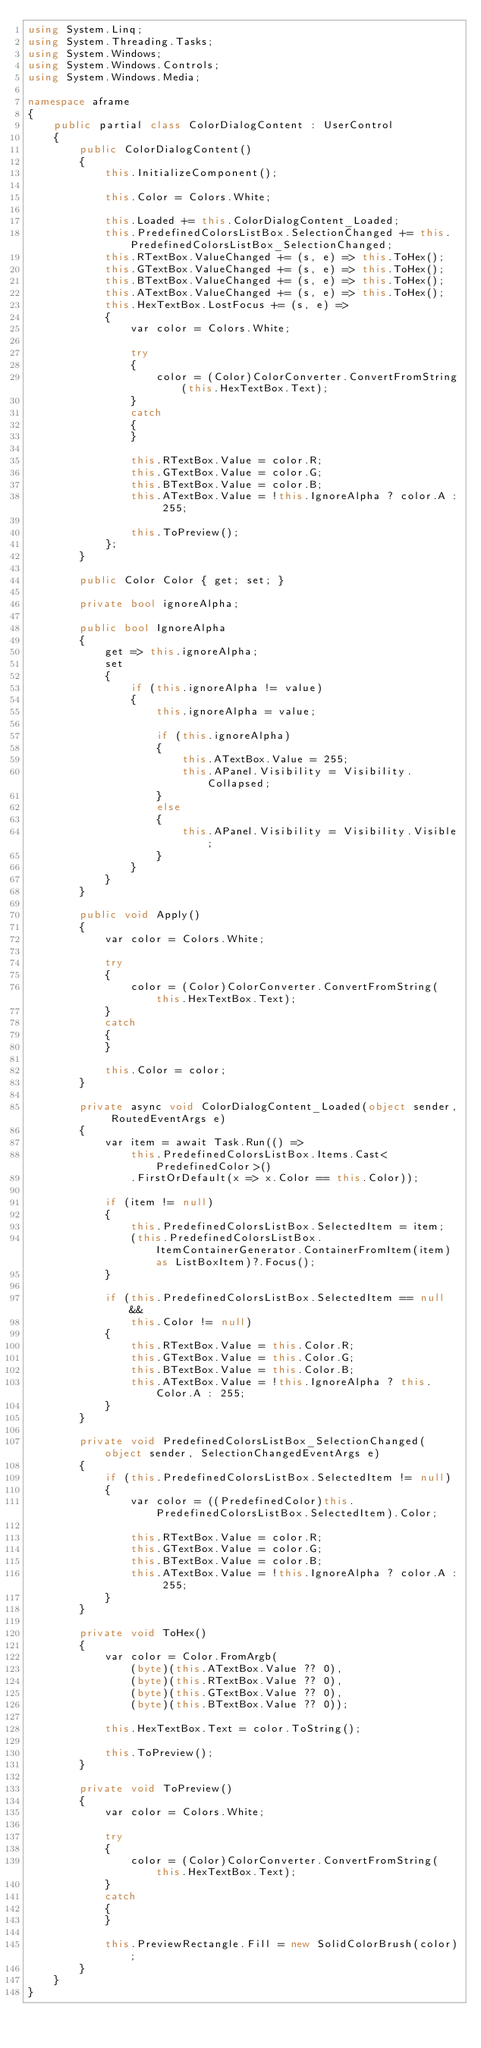<code> <loc_0><loc_0><loc_500><loc_500><_C#_>using System.Linq;
using System.Threading.Tasks;
using System.Windows;
using System.Windows.Controls;
using System.Windows.Media;

namespace aframe
{
    public partial class ColorDialogContent : UserControl
    {
        public ColorDialogContent()
        {
            this.InitializeComponent();

            this.Color = Colors.White;

            this.Loaded += this.ColorDialogContent_Loaded;
            this.PredefinedColorsListBox.SelectionChanged += this.PredefinedColorsListBox_SelectionChanged;
            this.RTextBox.ValueChanged += (s, e) => this.ToHex();
            this.GTextBox.ValueChanged += (s, e) => this.ToHex();
            this.BTextBox.ValueChanged += (s, e) => this.ToHex();
            this.ATextBox.ValueChanged += (s, e) => this.ToHex();
            this.HexTextBox.LostFocus += (s, e) =>
            {
                var color = Colors.White;

                try
                {
                    color = (Color)ColorConverter.ConvertFromString(this.HexTextBox.Text);
                }
                catch
                {
                }

                this.RTextBox.Value = color.R;
                this.GTextBox.Value = color.G;
                this.BTextBox.Value = color.B;
                this.ATextBox.Value = !this.IgnoreAlpha ? color.A : 255;

                this.ToPreview();
            };
        }

        public Color Color { get; set; }

        private bool ignoreAlpha;

        public bool IgnoreAlpha
        {
            get => this.ignoreAlpha;
            set
            {
                if (this.ignoreAlpha != value)
                {
                    this.ignoreAlpha = value;

                    if (this.ignoreAlpha)
                    {
                        this.ATextBox.Value = 255;
                        this.APanel.Visibility = Visibility.Collapsed;
                    }
                    else
                    {
                        this.APanel.Visibility = Visibility.Visible;
                    }
                }
            }
        }

        public void Apply()
        {
            var color = Colors.White;

            try
            {
                color = (Color)ColorConverter.ConvertFromString(this.HexTextBox.Text);
            }
            catch
            {
            }

            this.Color = color;
        }

        private async void ColorDialogContent_Loaded(object sender, RoutedEventArgs e)
        {
            var item = await Task.Run(() =>
                this.PredefinedColorsListBox.Items.Cast<PredefinedColor>()
                .FirstOrDefault(x => x.Color == this.Color));

            if (item != null)
            {
                this.PredefinedColorsListBox.SelectedItem = item;
                (this.PredefinedColorsListBox.ItemContainerGenerator.ContainerFromItem(item) as ListBoxItem)?.Focus();
            }

            if (this.PredefinedColorsListBox.SelectedItem == null &&
                this.Color != null)
            {
                this.RTextBox.Value = this.Color.R;
                this.GTextBox.Value = this.Color.G;
                this.BTextBox.Value = this.Color.B;
                this.ATextBox.Value = !this.IgnoreAlpha ? this.Color.A : 255;
            }
        }

        private void PredefinedColorsListBox_SelectionChanged(object sender, SelectionChangedEventArgs e)
        {
            if (this.PredefinedColorsListBox.SelectedItem != null)
            {
                var color = ((PredefinedColor)this.PredefinedColorsListBox.SelectedItem).Color;

                this.RTextBox.Value = color.R;
                this.GTextBox.Value = color.G;
                this.BTextBox.Value = color.B;
                this.ATextBox.Value = !this.IgnoreAlpha ? color.A : 255;
            }
        }

        private void ToHex()
        {
            var color = Color.FromArgb(
                (byte)(this.ATextBox.Value ?? 0),
                (byte)(this.RTextBox.Value ?? 0),
                (byte)(this.GTextBox.Value ?? 0),
                (byte)(this.BTextBox.Value ?? 0));

            this.HexTextBox.Text = color.ToString();

            this.ToPreview();
        }

        private void ToPreview()
        {
            var color = Colors.White;

            try
            {
                color = (Color)ColorConverter.ConvertFromString(this.HexTextBox.Text);
            }
            catch
            {
            }

            this.PreviewRectangle.Fill = new SolidColorBrush(color);
        }
    }
}
</code> 